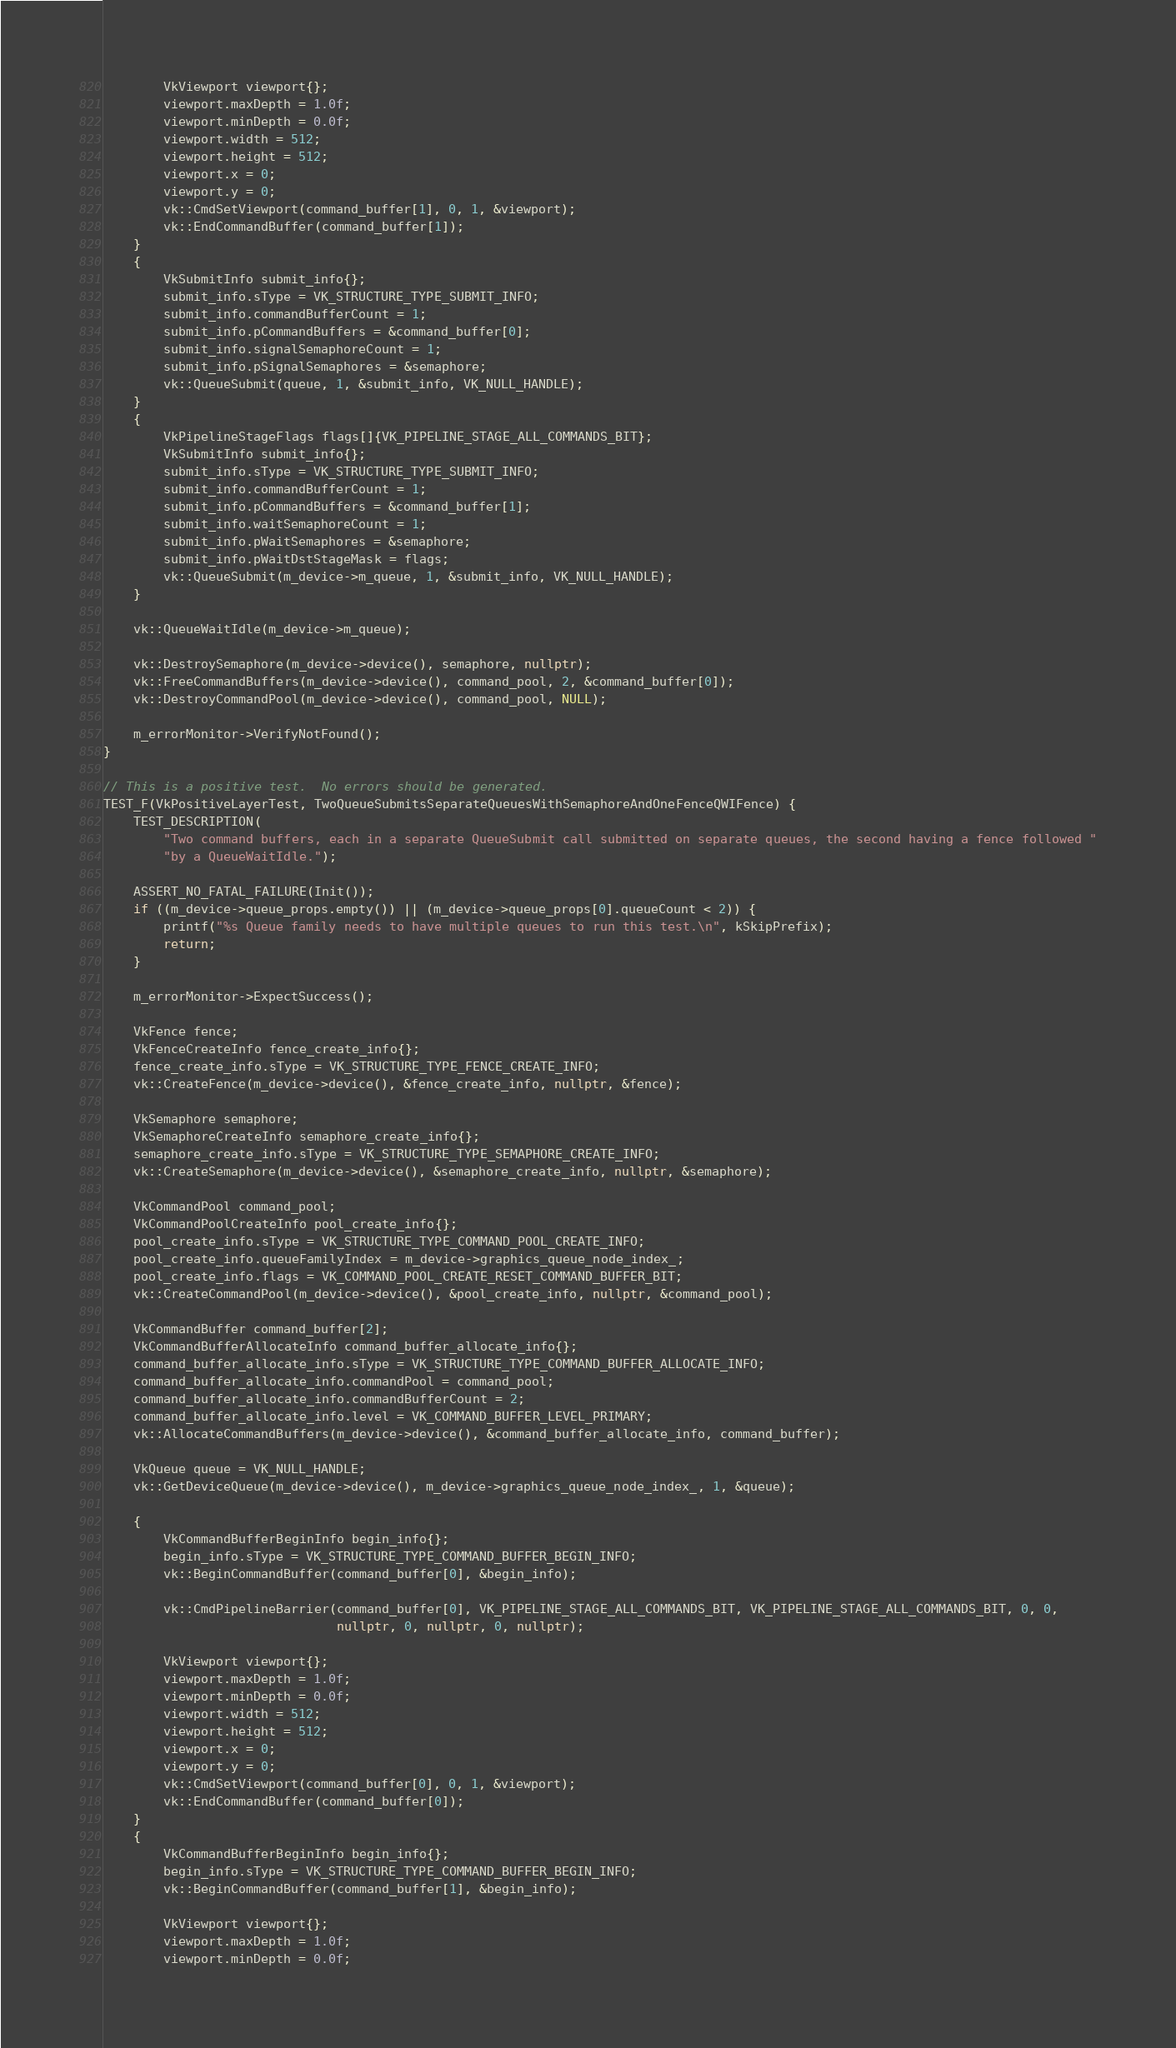Convert code to text. <code><loc_0><loc_0><loc_500><loc_500><_C++_>
        VkViewport viewport{};
        viewport.maxDepth = 1.0f;
        viewport.minDepth = 0.0f;
        viewport.width = 512;
        viewport.height = 512;
        viewport.x = 0;
        viewport.y = 0;
        vk::CmdSetViewport(command_buffer[1], 0, 1, &viewport);
        vk::EndCommandBuffer(command_buffer[1]);
    }
    {
        VkSubmitInfo submit_info{};
        submit_info.sType = VK_STRUCTURE_TYPE_SUBMIT_INFO;
        submit_info.commandBufferCount = 1;
        submit_info.pCommandBuffers = &command_buffer[0];
        submit_info.signalSemaphoreCount = 1;
        submit_info.pSignalSemaphores = &semaphore;
        vk::QueueSubmit(queue, 1, &submit_info, VK_NULL_HANDLE);
    }
    {
        VkPipelineStageFlags flags[]{VK_PIPELINE_STAGE_ALL_COMMANDS_BIT};
        VkSubmitInfo submit_info{};
        submit_info.sType = VK_STRUCTURE_TYPE_SUBMIT_INFO;
        submit_info.commandBufferCount = 1;
        submit_info.pCommandBuffers = &command_buffer[1];
        submit_info.waitSemaphoreCount = 1;
        submit_info.pWaitSemaphores = &semaphore;
        submit_info.pWaitDstStageMask = flags;
        vk::QueueSubmit(m_device->m_queue, 1, &submit_info, VK_NULL_HANDLE);
    }

    vk::QueueWaitIdle(m_device->m_queue);

    vk::DestroySemaphore(m_device->device(), semaphore, nullptr);
    vk::FreeCommandBuffers(m_device->device(), command_pool, 2, &command_buffer[0]);
    vk::DestroyCommandPool(m_device->device(), command_pool, NULL);

    m_errorMonitor->VerifyNotFound();
}

// This is a positive test.  No errors should be generated.
TEST_F(VkPositiveLayerTest, TwoQueueSubmitsSeparateQueuesWithSemaphoreAndOneFenceQWIFence) {
    TEST_DESCRIPTION(
        "Two command buffers, each in a separate QueueSubmit call submitted on separate queues, the second having a fence followed "
        "by a QueueWaitIdle.");

    ASSERT_NO_FATAL_FAILURE(Init());
    if ((m_device->queue_props.empty()) || (m_device->queue_props[0].queueCount < 2)) {
        printf("%s Queue family needs to have multiple queues to run this test.\n", kSkipPrefix);
        return;
    }

    m_errorMonitor->ExpectSuccess();

    VkFence fence;
    VkFenceCreateInfo fence_create_info{};
    fence_create_info.sType = VK_STRUCTURE_TYPE_FENCE_CREATE_INFO;
    vk::CreateFence(m_device->device(), &fence_create_info, nullptr, &fence);

    VkSemaphore semaphore;
    VkSemaphoreCreateInfo semaphore_create_info{};
    semaphore_create_info.sType = VK_STRUCTURE_TYPE_SEMAPHORE_CREATE_INFO;
    vk::CreateSemaphore(m_device->device(), &semaphore_create_info, nullptr, &semaphore);

    VkCommandPool command_pool;
    VkCommandPoolCreateInfo pool_create_info{};
    pool_create_info.sType = VK_STRUCTURE_TYPE_COMMAND_POOL_CREATE_INFO;
    pool_create_info.queueFamilyIndex = m_device->graphics_queue_node_index_;
    pool_create_info.flags = VK_COMMAND_POOL_CREATE_RESET_COMMAND_BUFFER_BIT;
    vk::CreateCommandPool(m_device->device(), &pool_create_info, nullptr, &command_pool);

    VkCommandBuffer command_buffer[2];
    VkCommandBufferAllocateInfo command_buffer_allocate_info{};
    command_buffer_allocate_info.sType = VK_STRUCTURE_TYPE_COMMAND_BUFFER_ALLOCATE_INFO;
    command_buffer_allocate_info.commandPool = command_pool;
    command_buffer_allocate_info.commandBufferCount = 2;
    command_buffer_allocate_info.level = VK_COMMAND_BUFFER_LEVEL_PRIMARY;
    vk::AllocateCommandBuffers(m_device->device(), &command_buffer_allocate_info, command_buffer);

    VkQueue queue = VK_NULL_HANDLE;
    vk::GetDeviceQueue(m_device->device(), m_device->graphics_queue_node_index_, 1, &queue);

    {
        VkCommandBufferBeginInfo begin_info{};
        begin_info.sType = VK_STRUCTURE_TYPE_COMMAND_BUFFER_BEGIN_INFO;
        vk::BeginCommandBuffer(command_buffer[0], &begin_info);

        vk::CmdPipelineBarrier(command_buffer[0], VK_PIPELINE_STAGE_ALL_COMMANDS_BIT, VK_PIPELINE_STAGE_ALL_COMMANDS_BIT, 0, 0,
                               nullptr, 0, nullptr, 0, nullptr);

        VkViewport viewport{};
        viewport.maxDepth = 1.0f;
        viewport.minDepth = 0.0f;
        viewport.width = 512;
        viewport.height = 512;
        viewport.x = 0;
        viewport.y = 0;
        vk::CmdSetViewport(command_buffer[0], 0, 1, &viewport);
        vk::EndCommandBuffer(command_buffer[0]);
    }
    {
        VkCommandBufferBeginInfo begin_info{};
        begin_info.sType = VK_STRUCTURE_TYPE_COMMAND_BUFFER_BEGIN_INFO;
        vk::BeginCommandBuffer(command_buffer[1], &begin_info);

        VkViewport viewport{};
        viewport.maxDepth = 1.0f;
        viewport.minDepth = 0.0f;</code> 